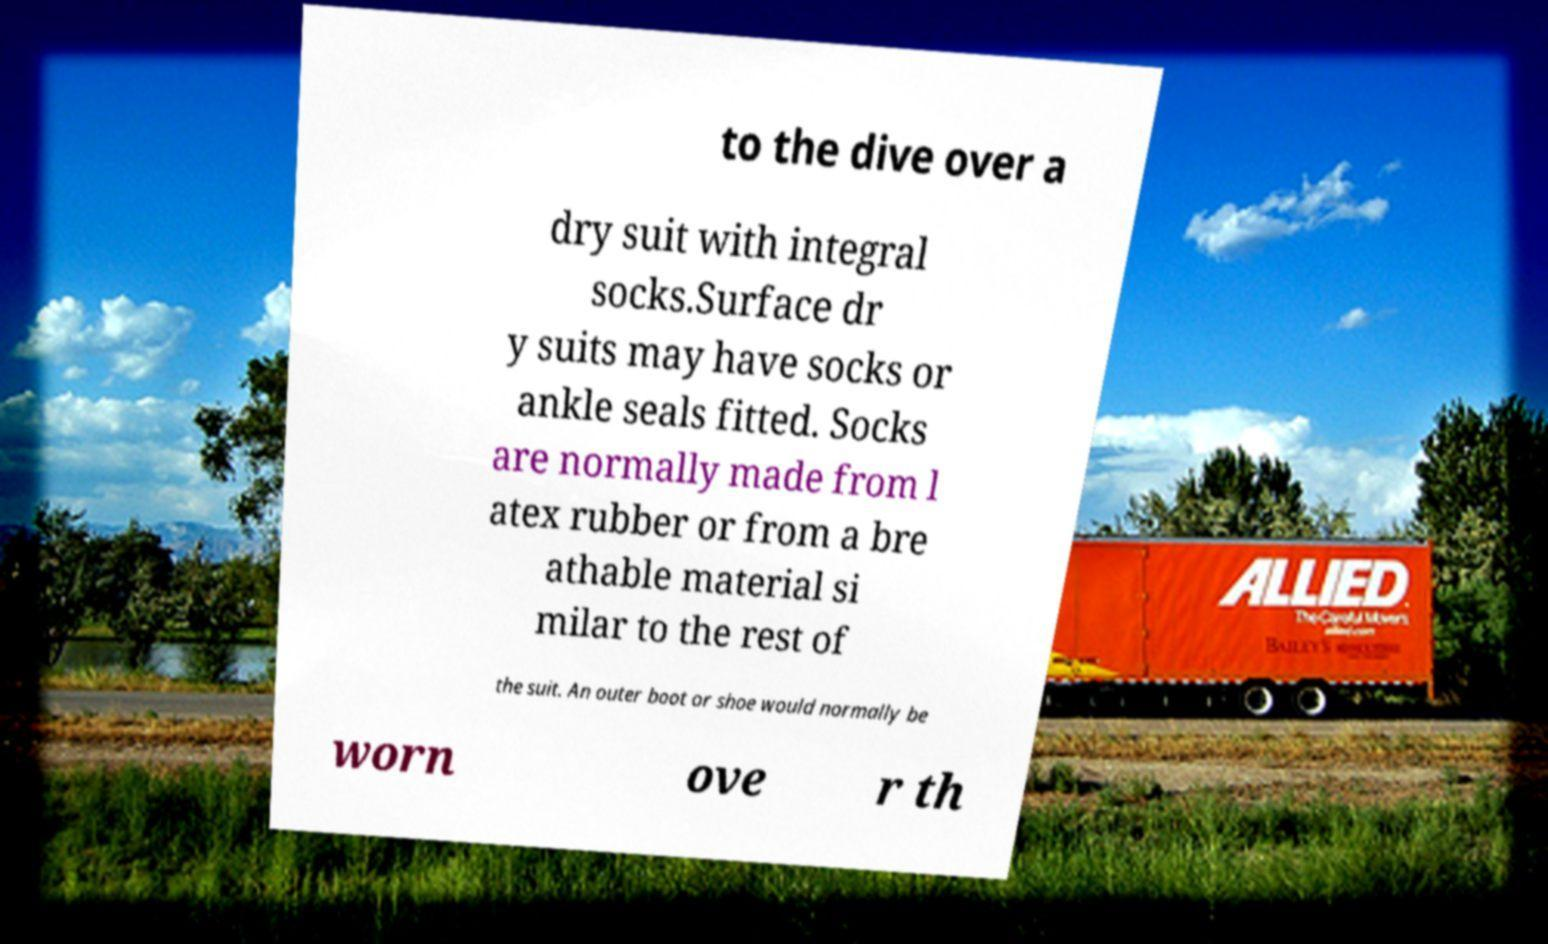Please read and relay the text visible in this image. What does it say? to the dive over a dry suit with integral socks.Surface dr y suits may have socks or ankle seals fitted. Socks are normally made from l atex rubber or from a bre athable material si milar to the rest of the suit. An outer boot or shoe would normally be worn ove r th 